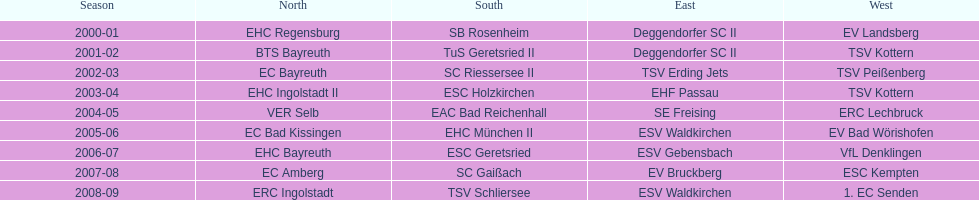How many times does deggendorfer sc ii appear on the list? 2. 